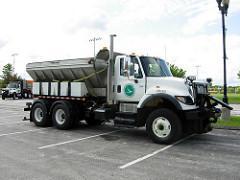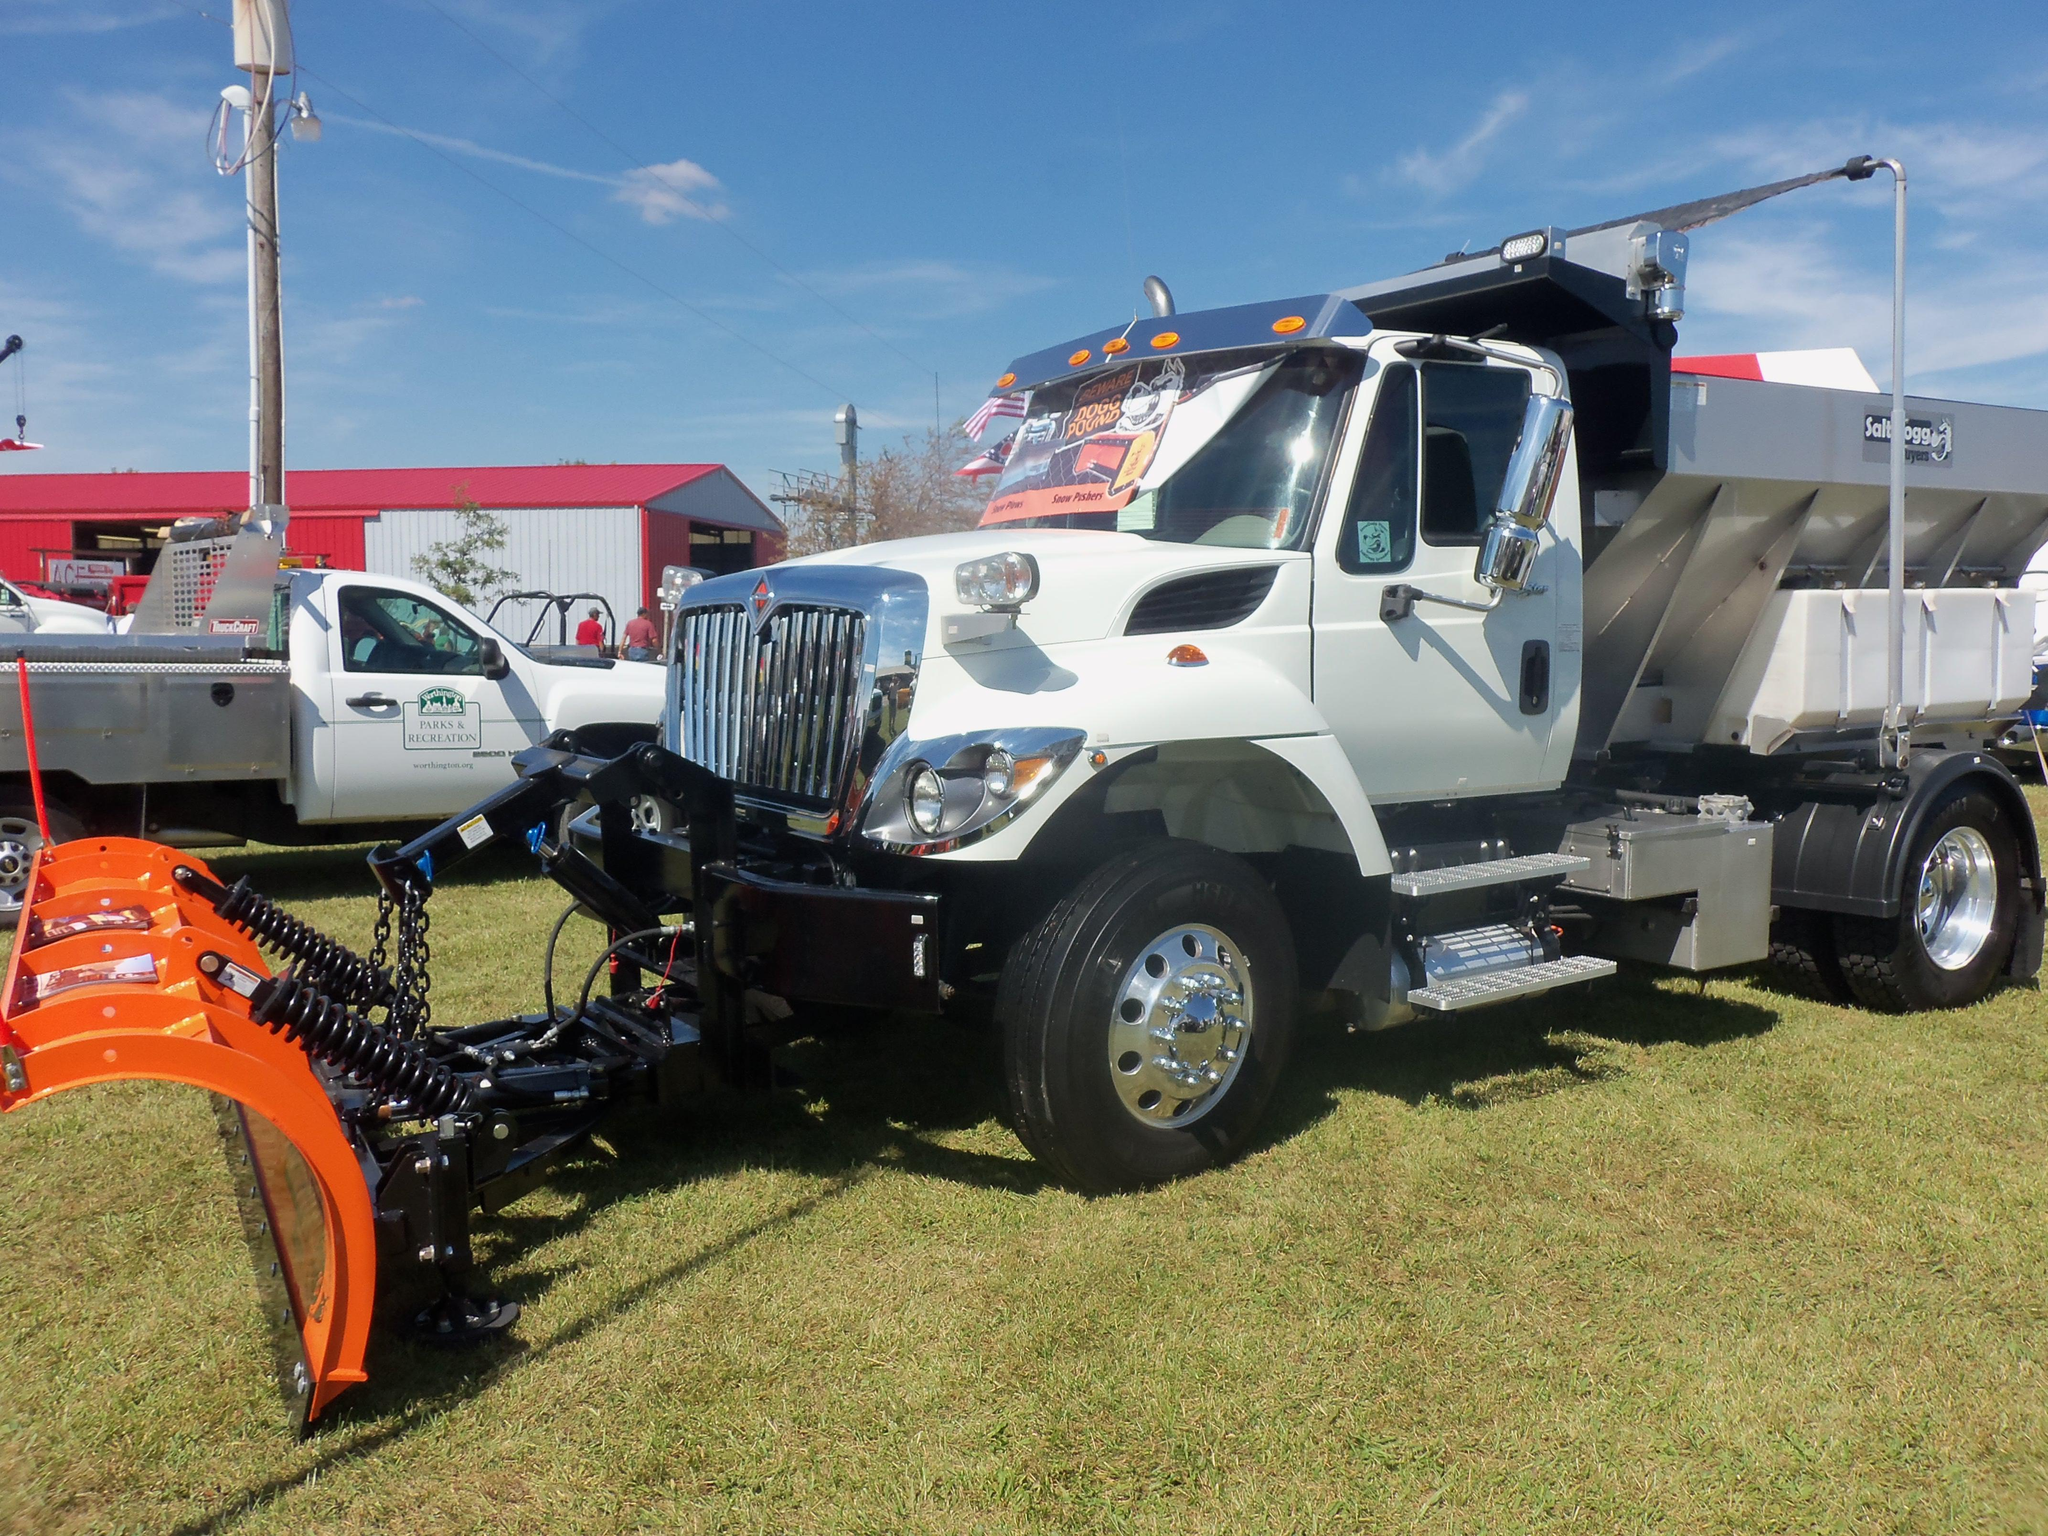The first image is the image on the left, the second image is the image on the right. For the images displayed, is the sentence "All trucks have attached shovels." factually correct? Answer yes or no. No. 